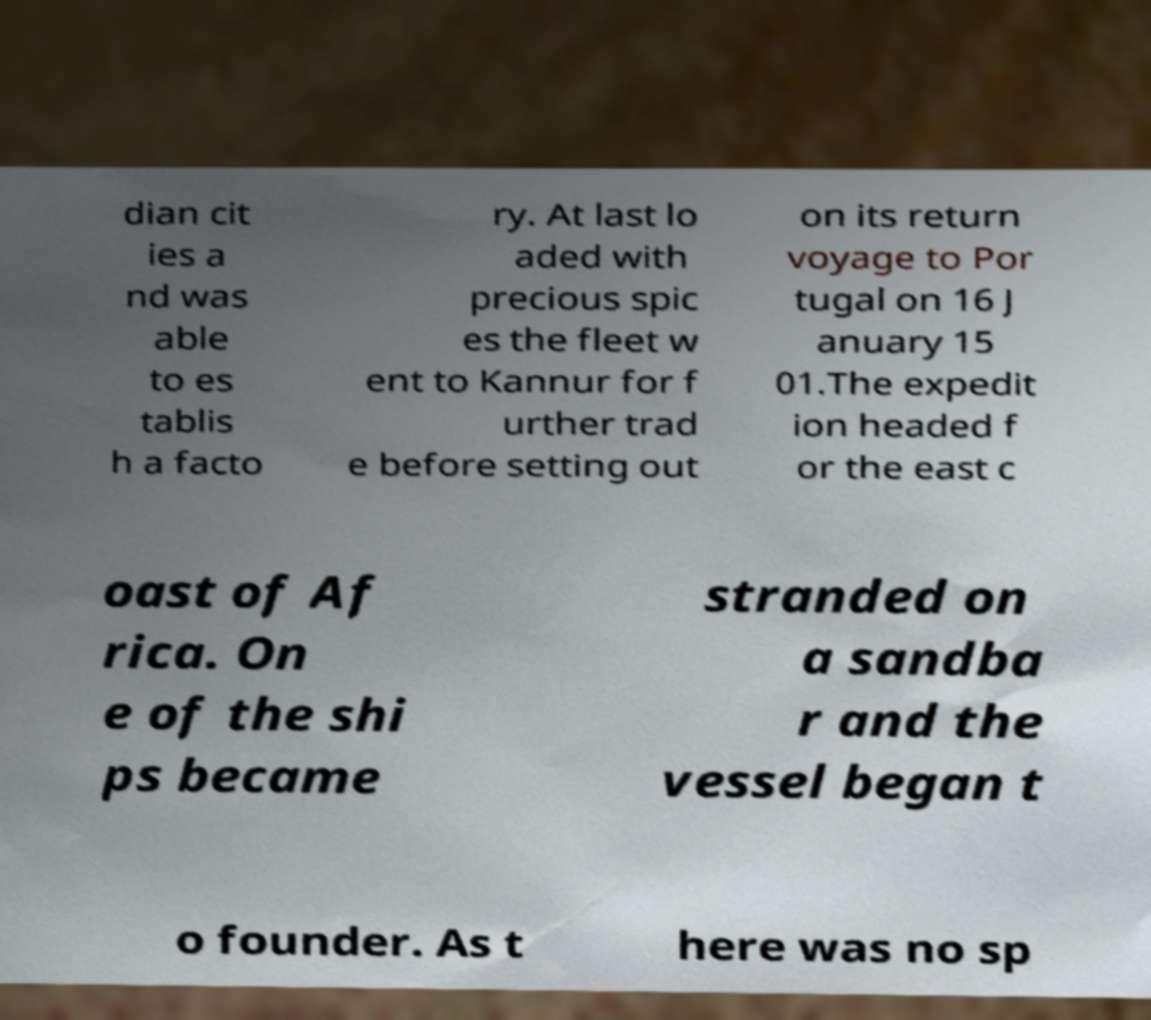There's text embedded in this image that I need extracted. Can you transcribe it verbatim? dian cit ies a nd was able to es tablis h a facto ry. At last lo aded with precious spic es the fleet w ent to Kannur for f urther trad e before setting out on its return voyage to Por tugal on 16 J anuary 15 01.The expedit ion headed f or the east c oast of Af rica. On e of the shi ps became stranded on a sandba r and the vessel began t o founder. As t here was no sp 